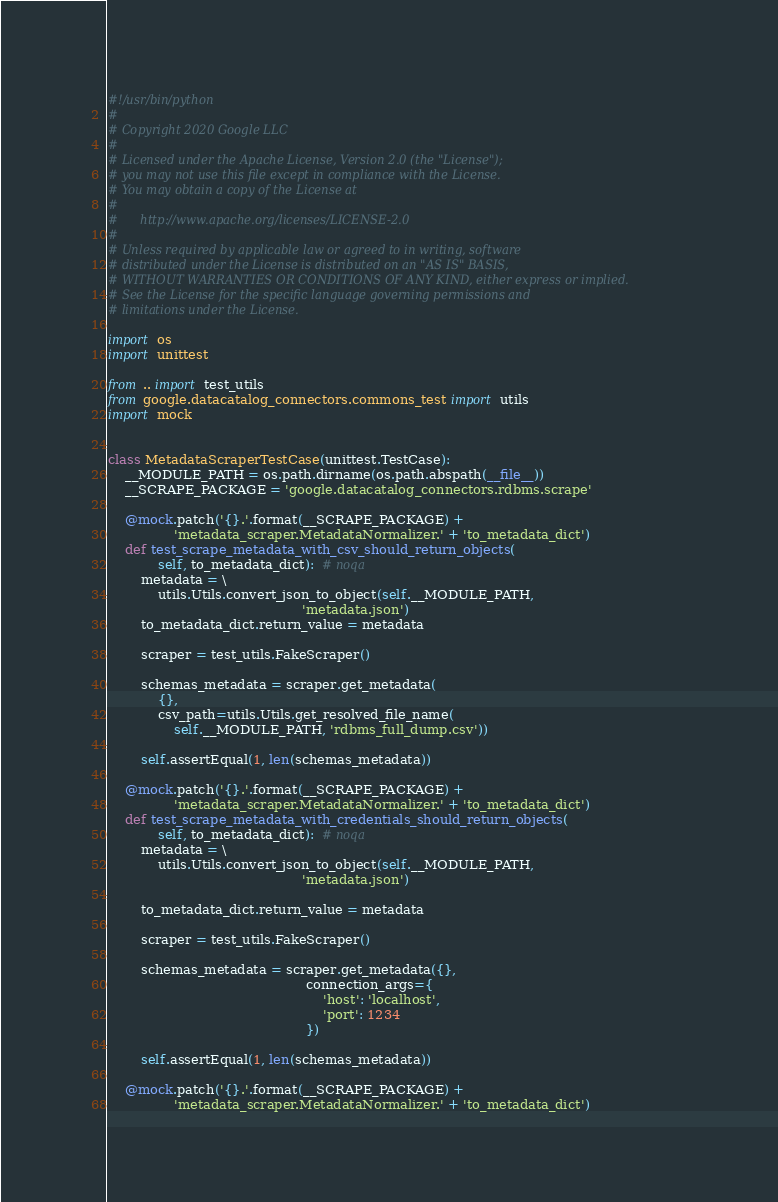Convert code to text. <code><loc_0><loc_0><loc_500><loc_500><_Python_>#!/usr/bin/python
#
# Copyright 2020 Google LLC
#
# Licensed under the Apache License, Version 2.0 (the "License");
# you may not use this file except in compliance with the License.
# You may obtain a copy of the License at
#
#      http://www.apache.org/licenses/LICENSE-2.0
#
# Unless required by applicable law or agreed to in writing, software
# distributed under the License is distributed on an "AS IS" BASIS,
# WITHOUT WARRANTIES OR CONDITIONS OF ANY KIND, either express or implied.
# See the License for the specific language governing permissions and
# limitations under the License.

import os
import unittest

from .. import test_utils
from google.datacatalog_connectors.commons_test import utils
import mock


class MetadataScraperTestCase(unittest.TestCase):
    __MODULE_PATH = os.path.dirname(os.path.abspath(__file__))
    __SCRAPE_PACKAGE = 'google.datacatalog_connectors.rdbms.scrape'

    @mock.patch('{}.'.format(__SCRAPE_PACKAGE) +
                'metadata_scraper.MetadataNormalizer.' + 'to_metadata_dict')
    def test_scrape_metadata_with_csv_should_return_objects(
            self, to_metadata_dict):  # noqa
        metadata = \
            utils.Utils.convert_json_to_object(self.__MODULE_PATH,
                                               'metadata.json')
        to_metadata_dict.return_value = metadata

        scraper = test_utils.FakeScraper()

        schemas_metadata = scraper.get_metadata(
            {},
            csv_path=utils.Utils.get_resolved_file_name(
                self.__MODULE_PATH, 'rdbms_full_dump.csv'))

        self.assertEqual(1, len(schemas_metadata))

    @mock.patch('{}.'.format(__SCRAPE_PACKAGE) +
                'metadata_scraper.MetadataNormalizer.' + 'to_metadata_dict')
    def test_scrape_metadata_with_credentials_should_return_objects(
            self, to_metadata_dict):  # noqa
        metadata = \
            utils.Utils.convert_json_to_object(self.__MODULE_PATH,
                                               'metadata.json')

        to_metadata_dict.return_value = metadata

        scraper = test_utils.FakeScraper()

        schemas_metadata = scraper.get_metadata({},
                                                connection_args={
                                                    'host': 'localhost',
                                                    'port': 1234
                                                })

        self.assertEqual(1, len(schemas_metadata))

    @mock.patch('{}.'.format(__SCRAPE_PACKAGE) +
                'metadata_scraper.MetadataNormalizer.' + 'to_metadata_dict')</code> 